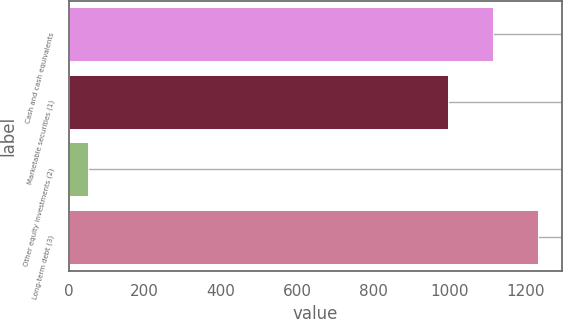Convert chart. <chart><loc_0><loc_0><loc_500><loc_500><bar_chart><fcel>Cash and cash equivalents<fcel>Marketable securities (1)<fcel>Other equity investments (2)<fcel>Long-term debt (3)<nl><fcel>1115.3<fcel>997<fcel>51<fcel>1234<nl></chart> 